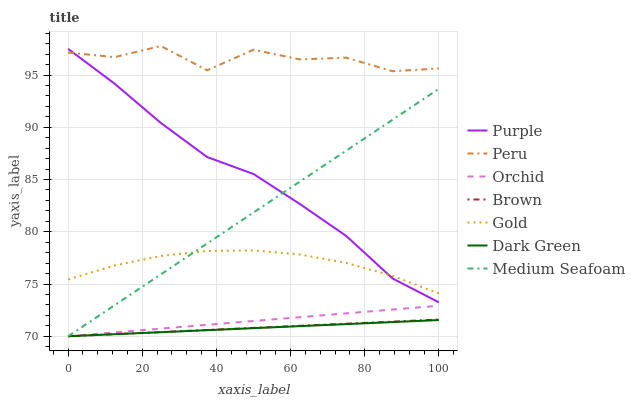Does Dark Green have the minimum area under the curve?
Answer yes or no. Yes. Does Peru have the maximum area under the curve?
Answer yes or no. Yes. Does Gold have the minimum area under the curve?
Answer yes or no. No. Does Gold have the maximum area under the curve?
Answer yes or no. No. Is Medium Seafoam the smoothest?
Answer yes or no. Yes. Is Peru the roughest?
Answer yes or no. Yes. Is Gold the smoothest?
Answer yes or no. No. Is Gold the roughest?
Answer yes or no. No. Does Brown have the lowest value?
Answer yes or no. Yes. Does Gold have the lowest value?
Answer yes or no. No. Does Peru have the highest value?
Answer yes or no. Yes. Does Gold have the highest value?
Answer yes or no. No. Is Brown less than Purple?
Answer yes or no. Yes. Is Purple greater than Orchid?
Answer yes or no. Yes. Does Brown intersect Medium Seafoam?
Answer yes or no. Yes. Is Brown less than Medium Seafoam?
Answer yes or no. No. Is Brown greater than Medium Seafoam?
Answer yes or no. No. Does Brown intersect Purple?
Answer yes or no. No. 